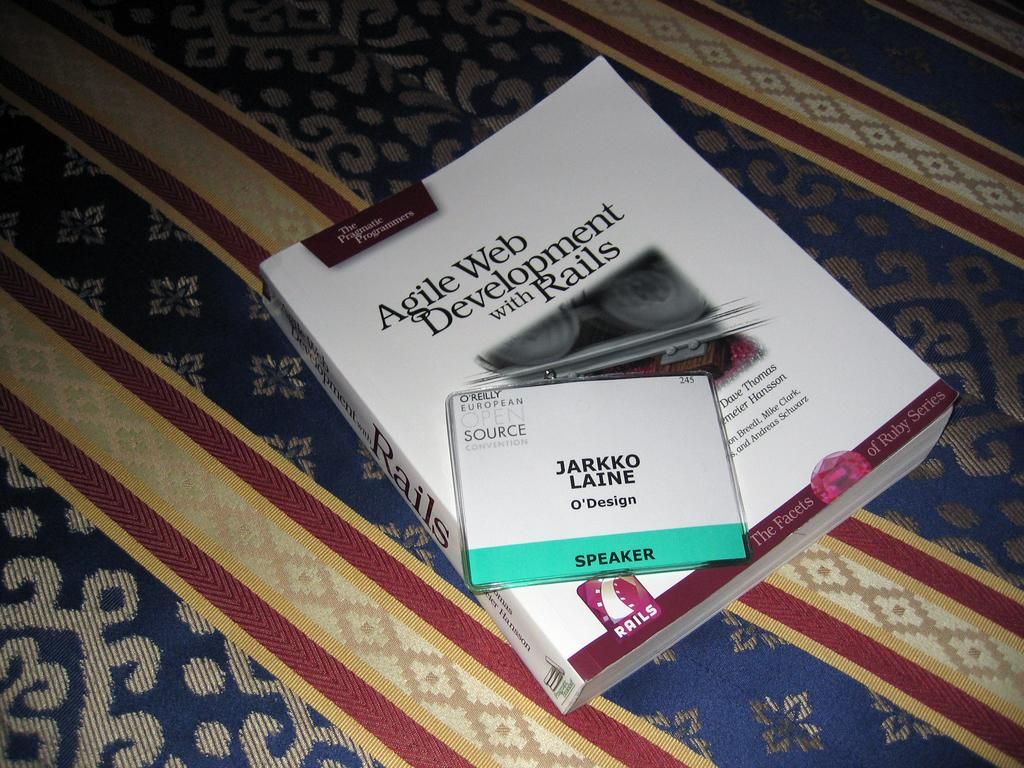What objects are in the foreground of the picture? There is a book and an identity card in the foreground of the picture. What are the objects placed on? The book and identity card are placed on a blanket-like thing. What type of rifle can be seen leaning against the blanket in the image? There is no rifle present in the image; it only features a book and an identity card placed on a blanket-like thing. 